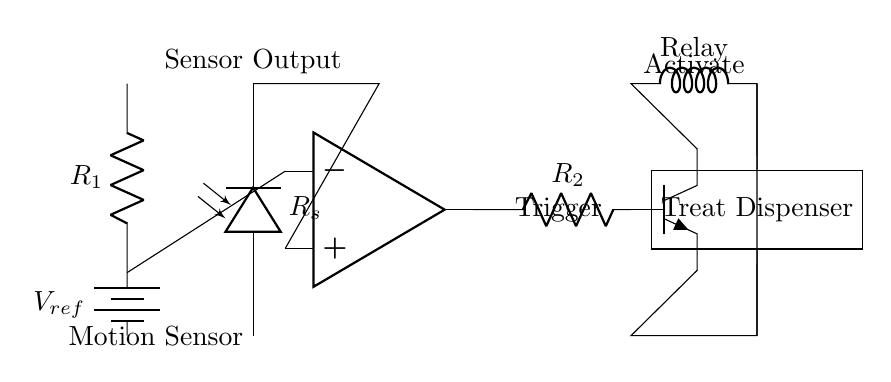What component is the motion sensor? The motion sensor is represented by the photodiode symbol, which shows that it detects light variations as motion.
Answer: Photodiode What does the reference voltage supply? The reference voltage, shown as a battery in the diagram, provides a fixed potential that is compared to the sensor output in the comparator.
Answer: Fixed potential How many resistors are present in the circuit? The circuit diagram shows two resistors: R1 and R2, which are indicated near the battery and the comparator output, respectively.
Answer: Two What type of output does the comparator provide? The comparator provides a triggering signal based on the comparison between the sensor output and the reference voltage, indicated by the connection to the transistor (Q1).
Answer: Trigger signal What is the purpose of the relay in this circuit? The relay is used to activate the treat dispenser when the comparator output indicates motion detected, allowing a larger current to control the dispenser.
Answer: Activate dispenser What activates the treat dispenser? The treat dispenser is activated when the relay receives the trigger signal from the output of the comparator, which occurs when motion is detected.
Answer: Relay trigger 